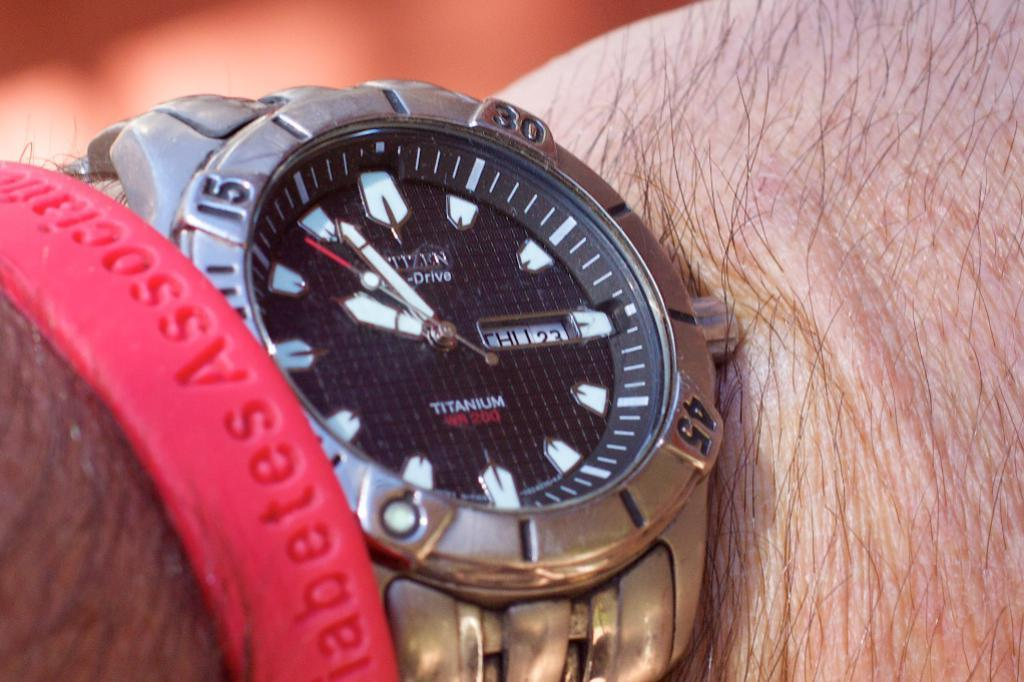<image>
Create a compact narrative representing the image presented. The nice silver watch is from the company Citizen 